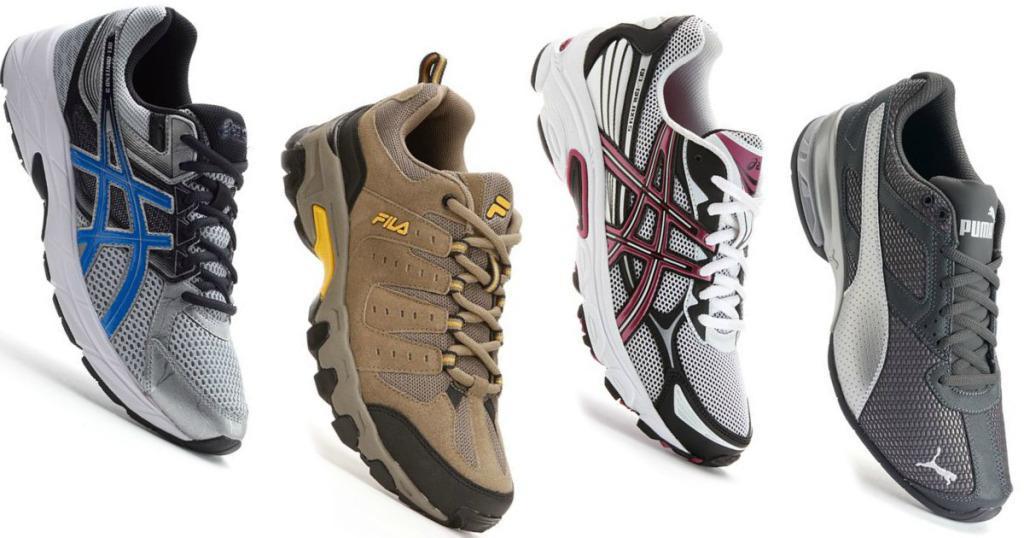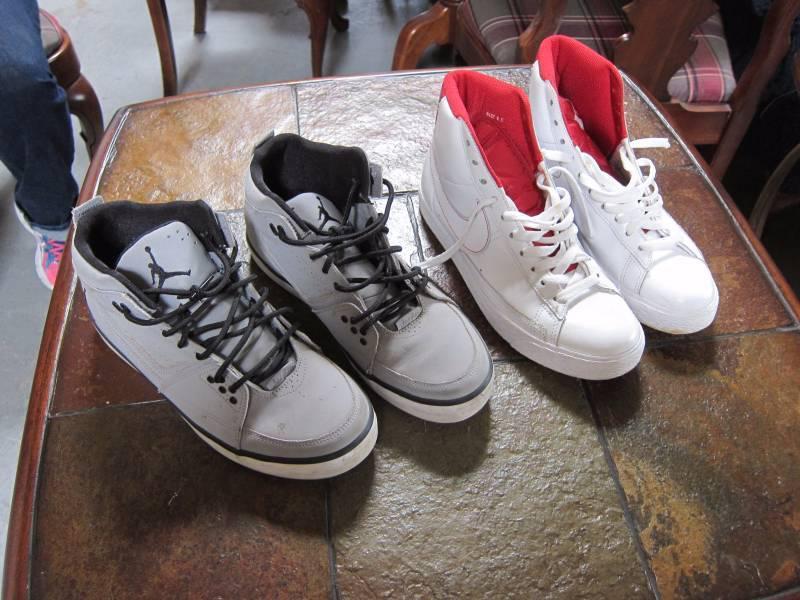The first image is the image on the left, the second image is the image on the right. For the images displayed, is the sentence "There are exactly eight shoes visible." factually correct? Answer yes or no. Yes. The first image is the image on the left, the second image is the image on the right. Given the left and right images, does the statement "At least one person is wearing the shoes." hold true? Answer yes or no. No. 